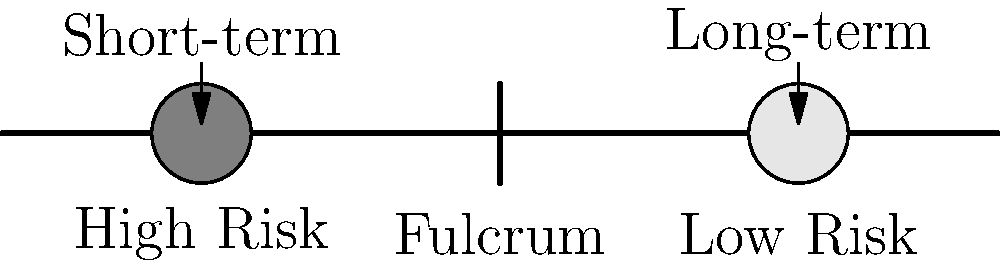In the context of investment strategies, the lever principle can be applied to balance risk and time horizons. Given the diagram above, which represents a risk-time lever for investment strategies, what would be the most appropriate action for a cautious long-term investor to maintain balance? To answer this question, let's analyze the diagram and apply the lever principle to investment strategies:

1. The lever represents the balance between risk and time horizon in investments.
2. The left side (shorter arm) represents high-risk, short-term investments.
3. The right side (longer arm) represents low-risk, long-term investments.
4. The fulcrum represents the point of balance in the investment strategy.

For a cautious long-term investor:

1. The investor's preference aligns with the right side of the lever (low-risk, long-term).
2. To maintain balance, we need to consider the lever principle: Force × Distance = Constant.
3. In investment terms, this translates to: Risk × Time Horizon = Constant.
4. To reduce risk (move weight to the right), we need to increase the time horizon (lengthen the right arm).
5. This means the investor should focus on extending the investment time horizon to justify lower-risk investments.

Therefore, the most appropriate action for a cautious long-term investor would be to extend the time horizon of their investments, allowing them to maintain a lower risk profile while still achieving balance in their investment strategy.
Answer: Extend the investment time horizon 